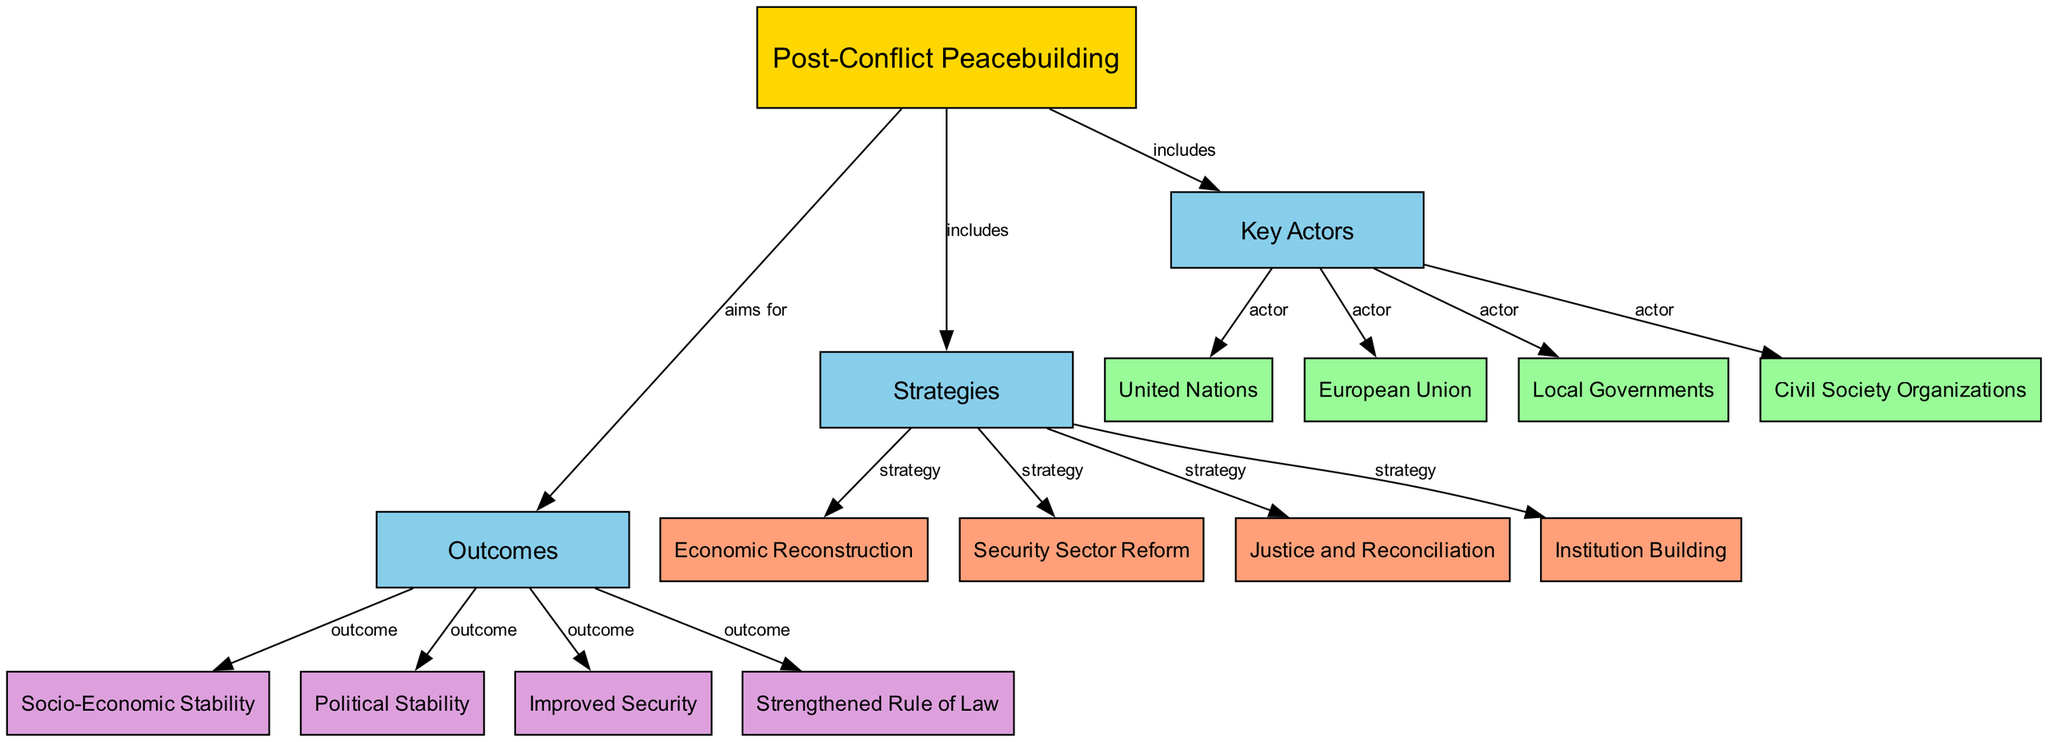What is the main topic of the diagram? The diagram's central theme is indicated by the main node labeled "Post-Conflict Peacebuilding." This node is the highest-level topic, representing the focus of the entire diagram.
Answer: Post-Conflict Peacebuilding How many key actors are identified in the diagram? The diagram lists four key actors, illustrated as entities under the "Key Actors" node: United Nations, European Union, Local Governments, and Civil Society Organizations. Counting these, we find there are four actors.
Answer: 4 What are the strategies included in post-conflict peacebuilding? The strategies can be found by looking at the node labeled "Strategies." Under this node, four strategies are specified. We identify these as Economic Reconstruction, Security Sector Reform, Justice and Reconciliation, and Institution Building.
Answer: Economic Reconstruction, Security Sector Reform, Justice and Reconciliation, Institution Building Which outcome is linked to improved security? The diagram indicates outcomes as nodes under the "Outcomes" section. Specifically, under the label "Improved Security," it is evident that this is one of the highlighted outcomes sought through the strategies implemented in peacebuilding efforts.
Answer: Improved Security How do the strategies connect to the outcomes in post-conflict peacebuilding? To answer this, we analyze the relationships in the diagram. The "Strategies" node is connected to the "Outcomes" node with the label "aims for." Each strategy aims to achieve certain outcomes listed as nodes under "Outcomes." Thus, the strategies directly influence the results in a post-conflict scenario.
Answer: Direct influence What type of organizations are included as key actors? By inspecting the "Key Actors" node, we can see that one of the entities listed is "Civil Society Organizations," which denotes the involvement of various non-governmental and grassroots groups crucial in peacebuilding efforts.
Answer: Civil Society Organizations Which two outcomes are related to political aspects? In reviewing the "Outcomes" section, we find "Political Stability" and "Strengthened Rule of Law" enumerated. These outcomes relate explicitly to the stability and governance aspects of post-conflict scenarios.
Answer: Political Stability, Strengthened Rule of Law What does the "includes" label indicate between the main topic and subcategories? The "includes" label represents a direct relationship where it specifies that the main topic, "Post-Conflict Peacebuilding," encompasses all the items listed under its subcategories: Key Actors, Strategies, and Outcomes. This informs us that these elements are essential components of the overall concept.
Answer: Encompasses essential components 